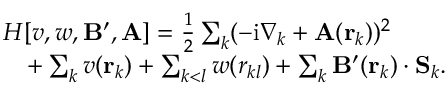Convert formula to latex. <formula><loc_0><loc_0><loc_500><loc_500>\begin{array} { r l } & { H [ v , w , B ^ { \prime } , A ] = \frac { 1 } { 2 } \sum _ { k } ( - i \nabla _ { k } + A ( r _ { k } ) ) ^ { 2 } } \\ & { \quad + \sum _ { k } v ( r _ { k } ) + \sum _ { k < l } w ( r _ { k l } ) + \sum _ { k } B ^ { \prime } ( r _ { k } ) \cdot S _ { k } . } \end{array}</formula> 